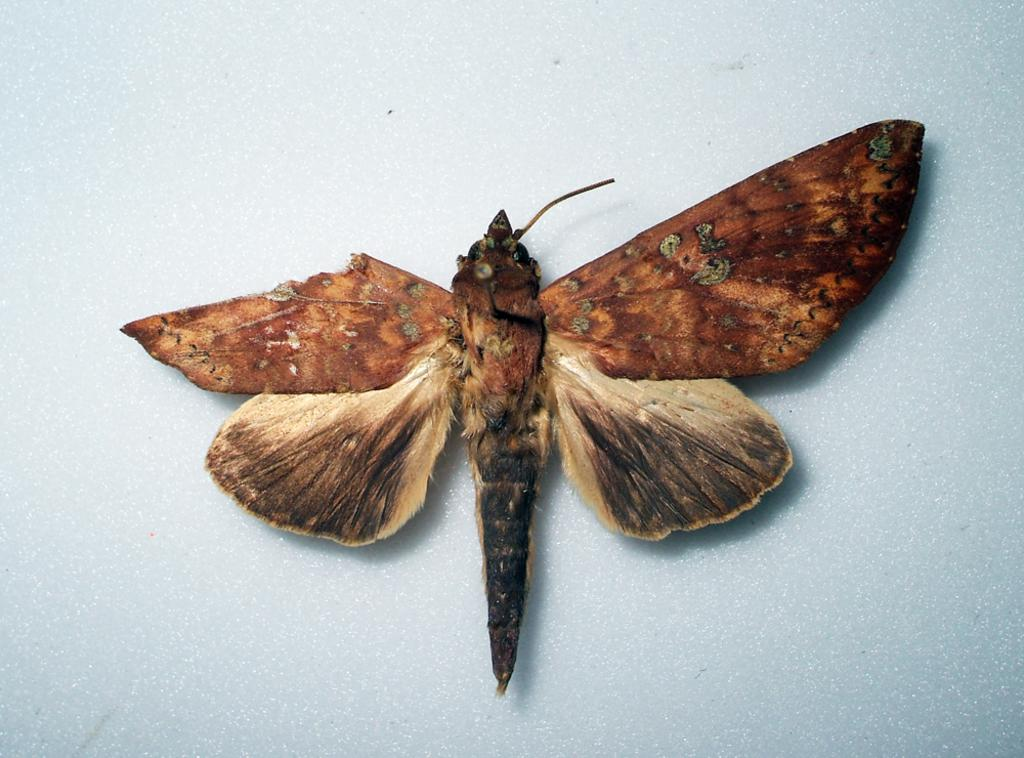What is the main subject in the image? There is a sphinx in the image. What type of substance is on the desk next to the sphinx in the image? There is no desk present in the image, as it only features a sphinx. 